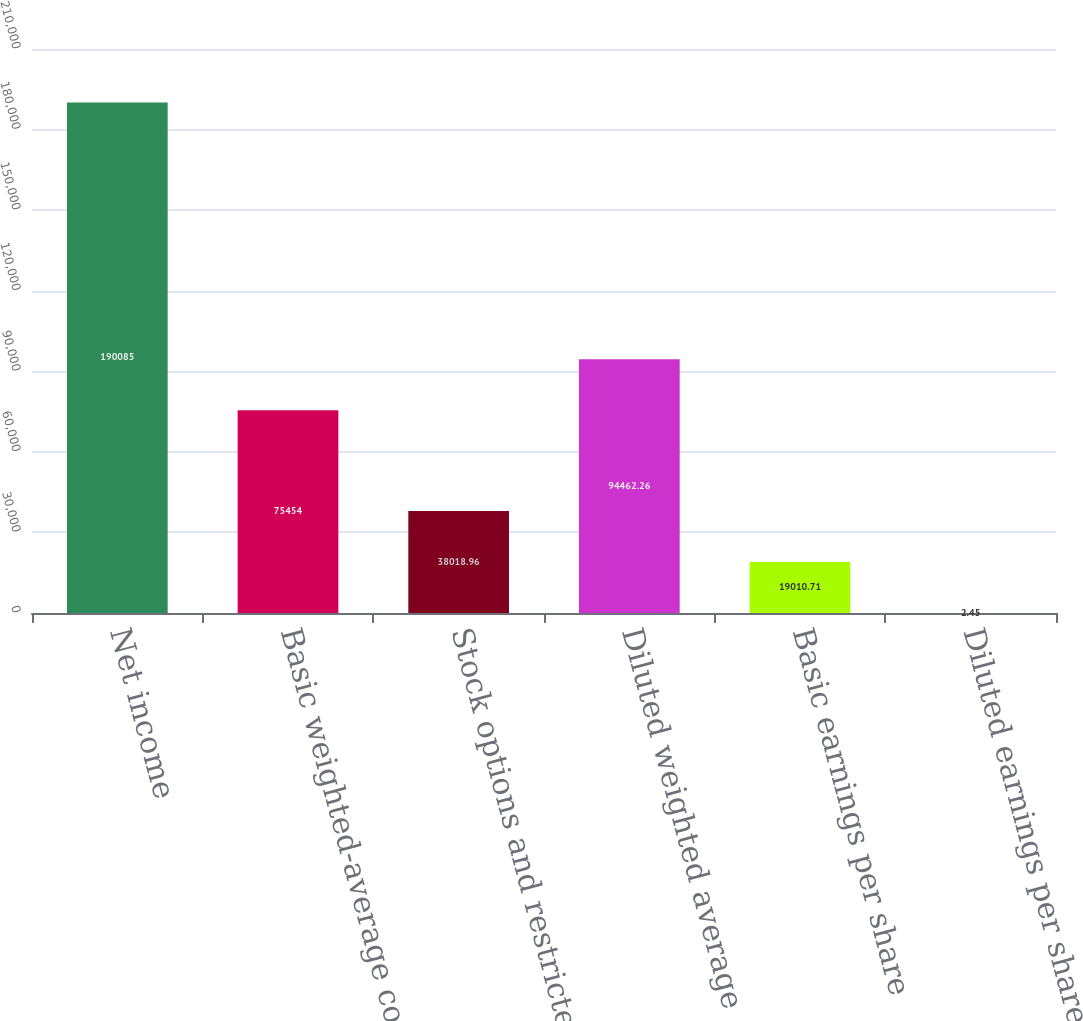<chart> <loc_0><loc_0><loc_500><loc_500><bar_chart><fcel>Net income<fcel>Basic weighted-average common<fcel>Stock options and restricted<fcel>Diluted weighted average<fcel>Basic earnings per share<fcel>Diluted earnings per share<nl><fcel>190085<fcel>75454<fcel>38019<fcel>94462.3<fcel>19010.7<fcel>2.45<nl></chart> 